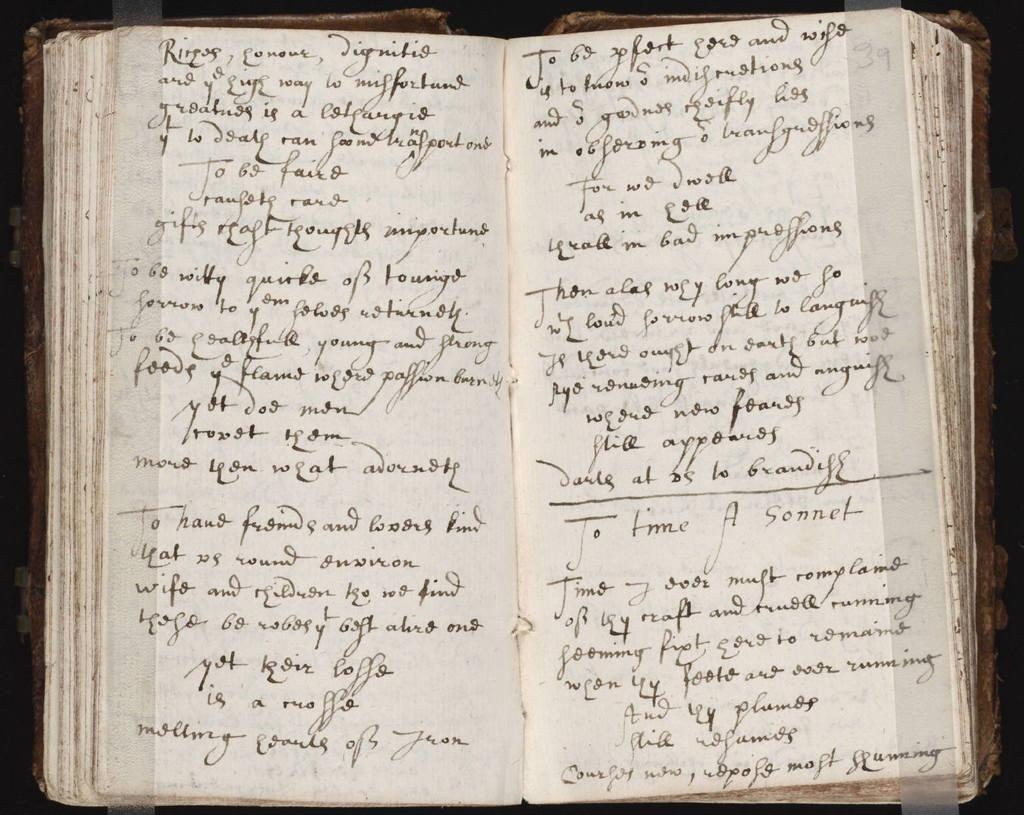What is present on the pages of the book in the image? There are texts on the pages of a book. What color are the pages of the book? The pages of the book are white in color. How would you describe the background of the image? The background of the image is dark in color. What type of roll is being prepared in the image? There is no roll being prepared in the image; it only features a book with text on its pages. 